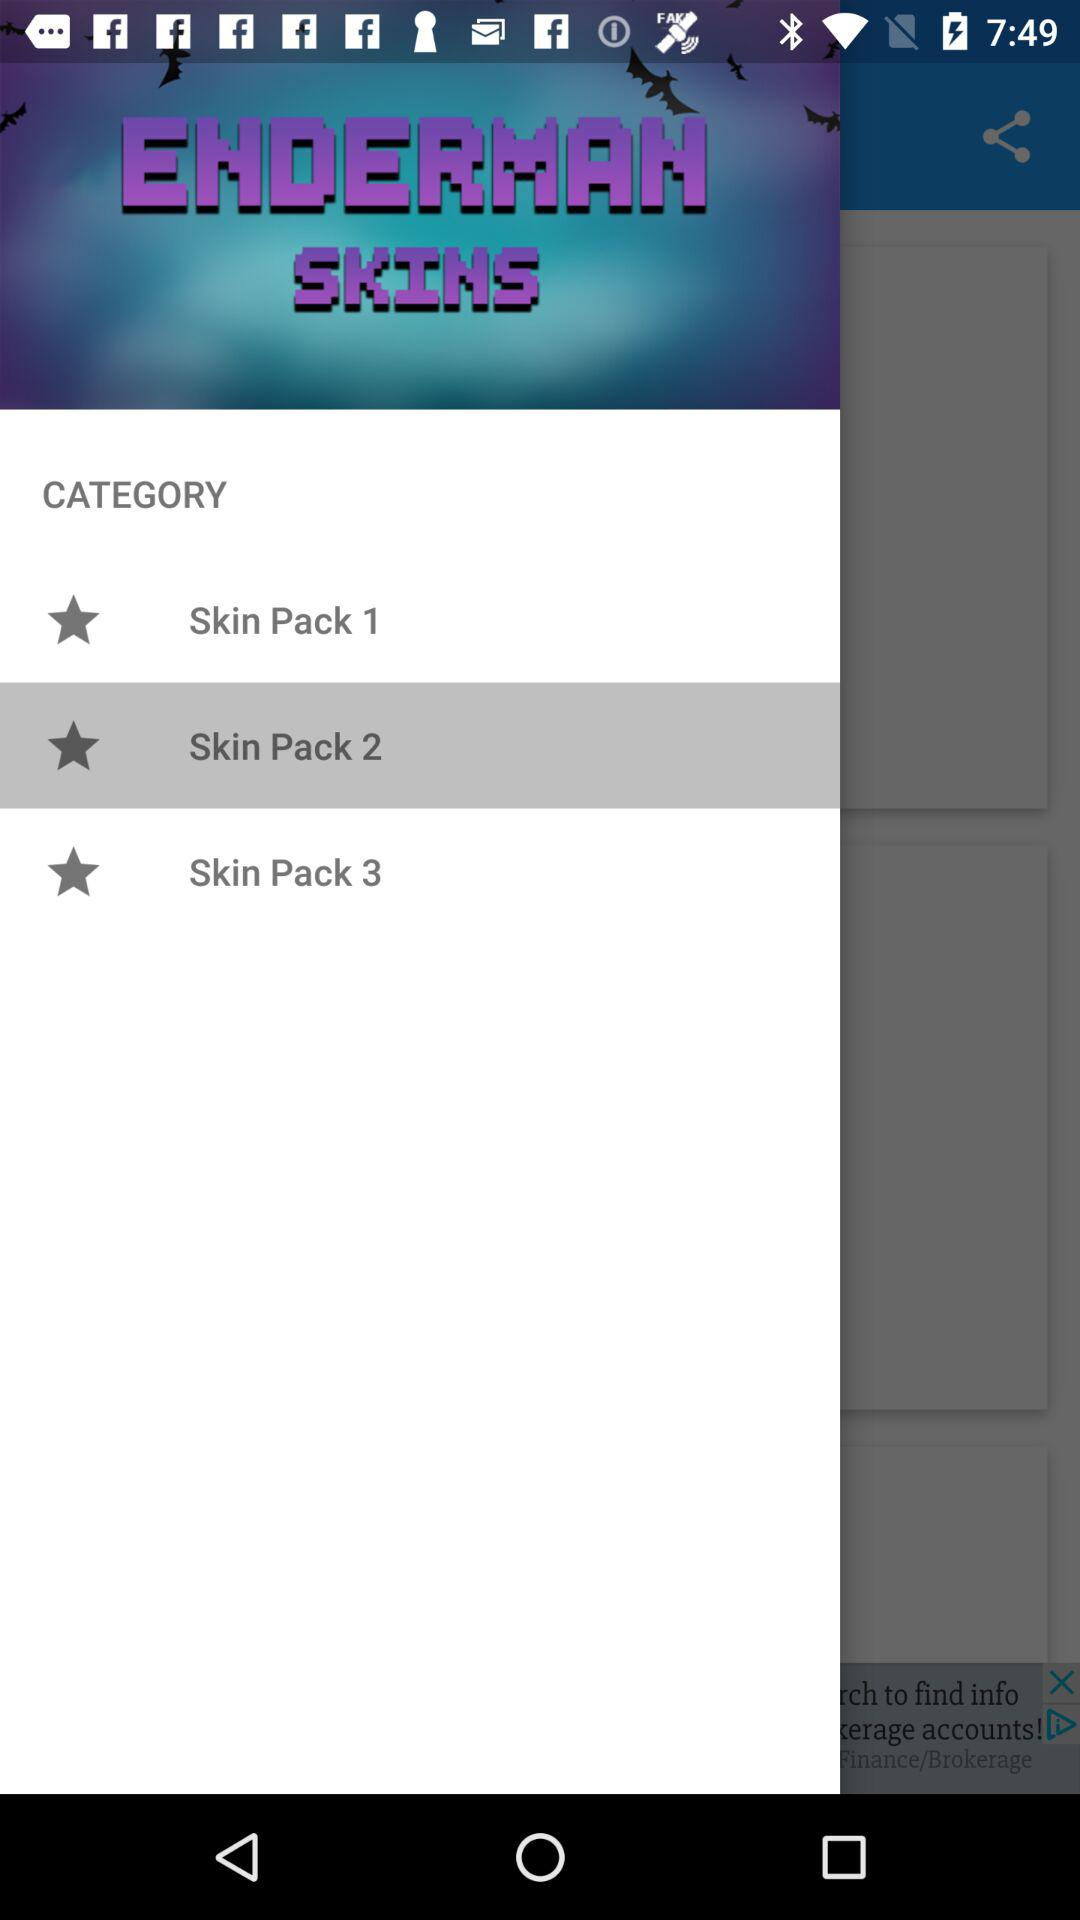How many skin packs are available?
Answer the question using a single word or phrase. 3 